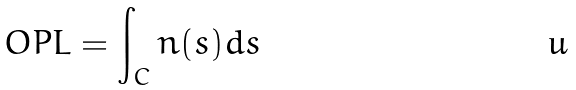Convert formula to latex. <formula><loc_0><loc_0><loc_500><loc_500>O P L = \int _ { C } n ( s ) d s</formula> 